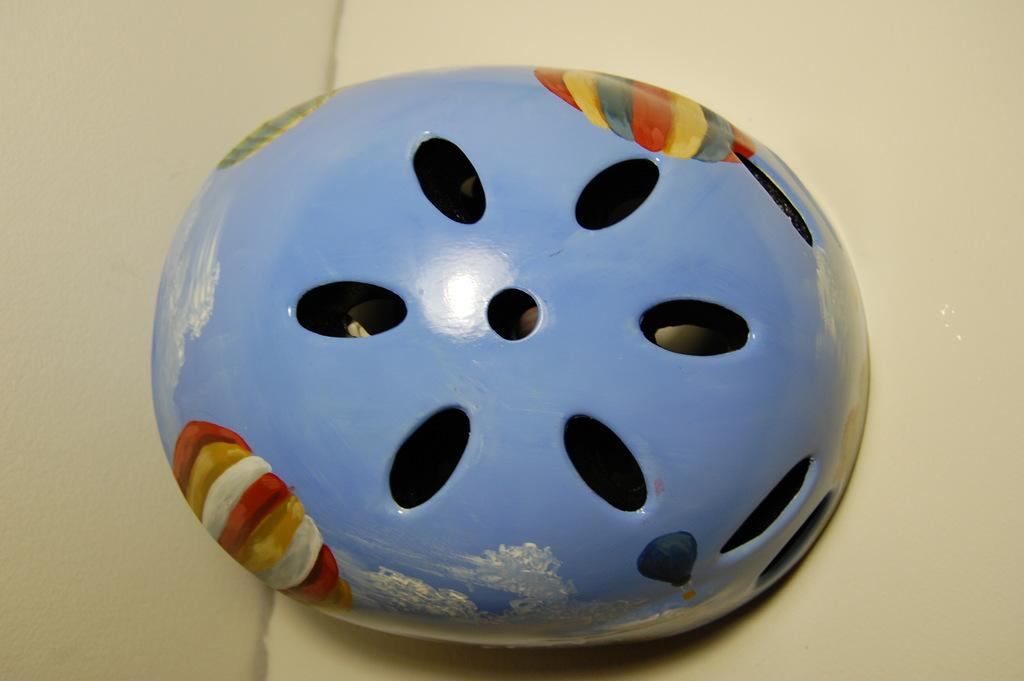What is the shape of the main structure in the image? The main structure in the image is oval-shaped. What can be seen on the surface of the structure? The structure has paintings on it. What is the color or material of the surface on which the structure is placed? The structure is placed on a cream surface. What type of weather can be seen in the image? There is no indication of weather in the image, as it focuses on the oval-shaped structure and its surroundings. Can you tell me how many cows are present in the image? There are no cows present in the image; it features an oval-shaped structure with paintings on it. 